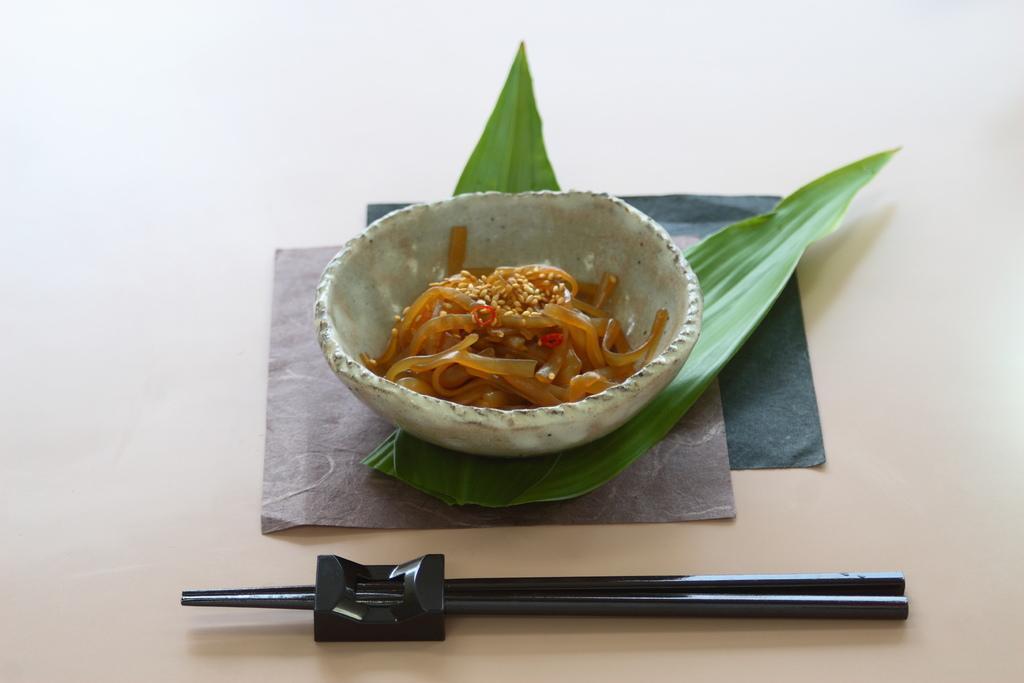Can you describe this image briefly? a bowl containing noodles is placed on leaves. in front of that there is a pair of chopsticks. 